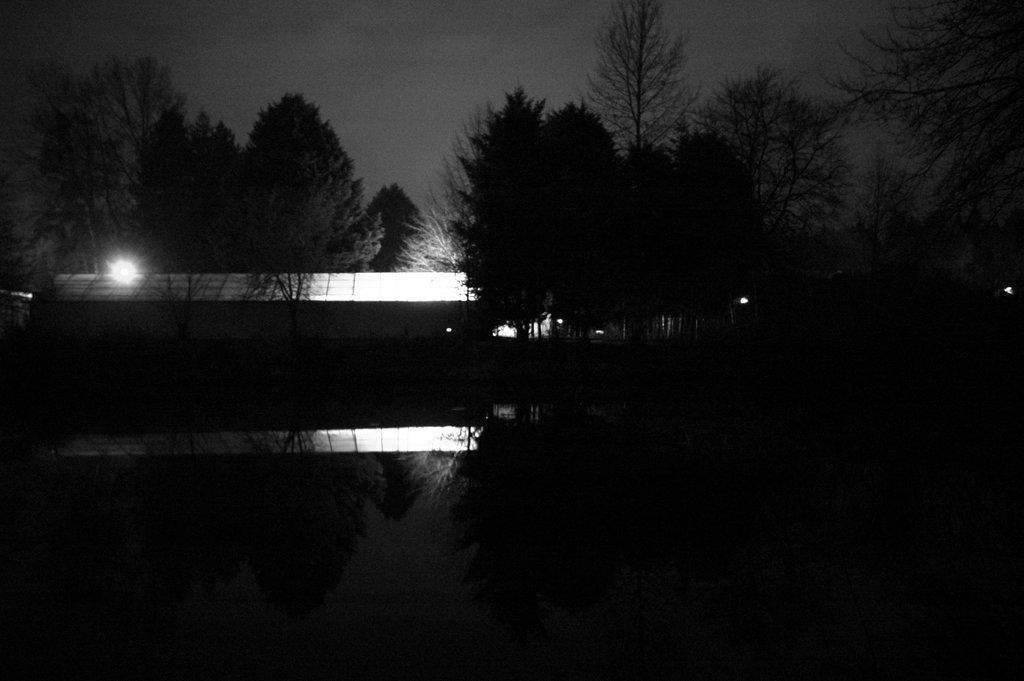What is the overall lighting condition in the image? The image is dark. What type of natural elements can be seen in the image? There are trees in the image. What artificial elements can be seen in the image? There are lights in the image. What type of structures are present in the image? There are sheds in the image. How much dust can be seen on the patch of grass in the image? There is no patch of grass visible in the image, and therefore no dust can be observed. 